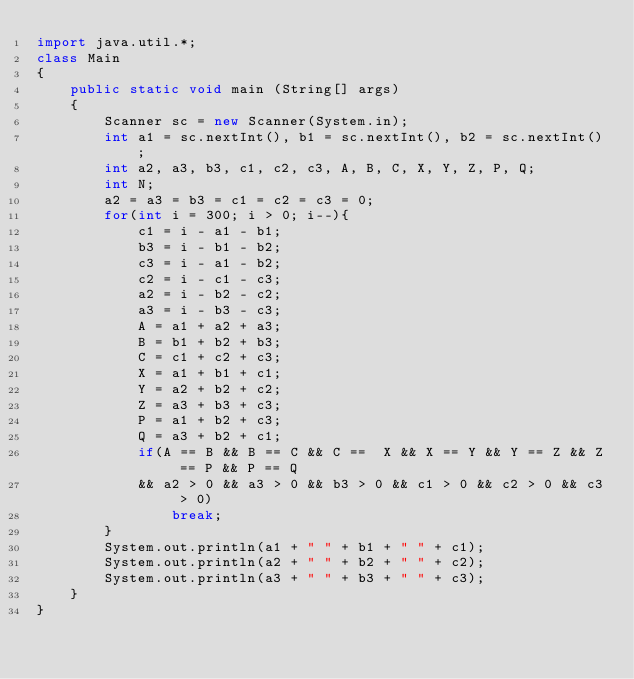<code> <loc_0><loc_0><loc_500><loc_500><_Java_>import java.util.*;
class Main
{
    public static void main (String[] args)
    {
        Scanner sc = new Scanner(System.in);
        int a1 = sc.nextInt(), b1 = sc.nextInt(), b2 = sc.nextInt();
        int a2, a3, b3, c1, c2, c3, A, B, C, X, Y, Z, P, Q;
        int N;
        a2 = a3 = b3 = c1 = c2 = c3 = 0;
        for(int i = 300; i > 0; i--){
            c1 = i - a1 - b1;
            b3 = i - b1 - b2;
            c3 = i - a1 - b2;
            c2 = i - c1 - c3;
            a2 = i - b2 - c2;
            a3 = i - b3 - c3;
            A = a1 + a2 + a3;
            B = b1 + b2 + b3;
            C = c1 + c2 + c3;
            X = a1 + b1 + c1;
            Y = a2 + b2 + c2;
            Z = a3 + b3 + c3;
            P = a1 + b2 + c3;
            Q = a3 + b2 + c1;
            if(A == B && B == C && C ==  X && X == Y && Y == Z && Z == P && P == Q
            && a2 > 0 && a3 > 0 && b3 > 0 && c1 > 0 && c2 > 0 && c3 > 0)
                break;
        }
        System.out.println(a1 + " " + b1 + " " + c1);
        System.out.println(a2 + " " + b2 + " " + c2);
        System.out.println(a3 + " " + b3 + " " + c3);
    }
}</code> 